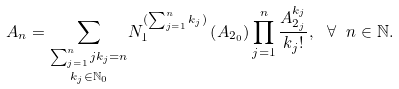Convert formula to latex. <formula><loc_0><loc_0><loc_500><loc_500>A _ { n } = \underset { k _ { j } \in \mathbb { N } _ { 0 } } { \sum _ { \sum _ { j = 1 } ^ { n } j k _ { j } = n } } N _ { 1 } ^ { ( \sum _ { j = 1 } ^ { n } k _ { j } ) } \left ( A _ { 2 _ { 0 } } \right ) \prod _ { j = 1 } ^ { n } \frac { A _ { 2 _ { j } } ^ { k _ { j } } } { k _ { j } ! } , \ \forall \ n \in \mathbb { N } .</formula> 